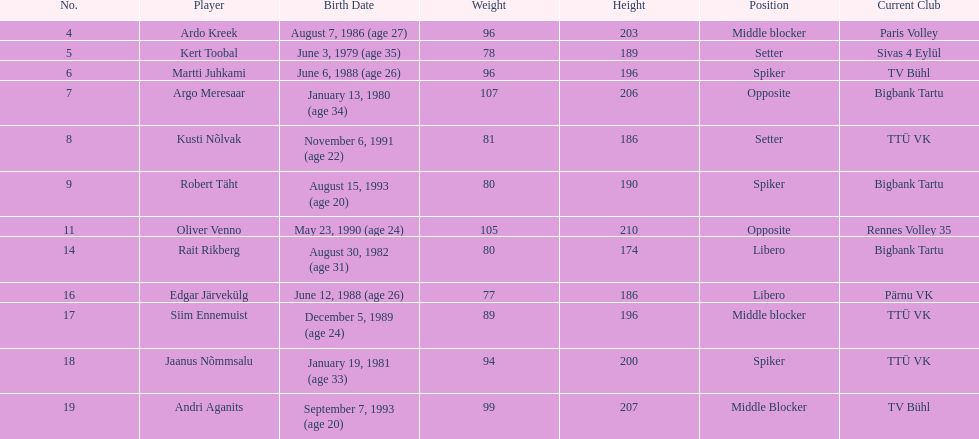What are the total number of players from france? 2. 